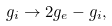<formula> <loc_0><loc_0><loc_500><loc_500>g _ { i } \to 2 g _ { e } - g _ { i } ,</formula> 